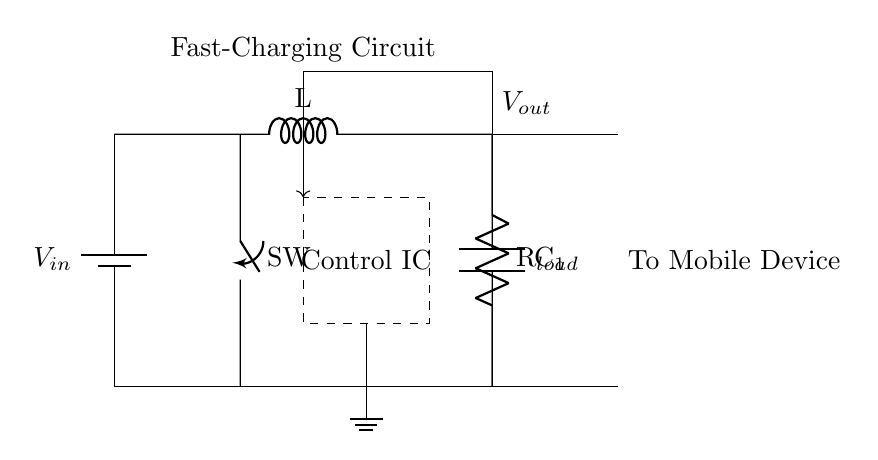What is the input voltage of this circuit? The voltage is indicated as V in the battery symbol at the start of the circuit, where the power source is labeled as V in the schematic.
Answer: V What is the function of the switch in the circuit? The switch is used to control the flow of current, allowing the user to enable or disable the connection to the load. Its position can break or complete the circuit, influencing the charging process.
Answer: Control flow What component is responsible for voltage regulation? The control IC is responsible for managing the output voltage and ensures it stays within specified limits as the load varies. The dashed rectangle in the diagram represents this component.
Answer: Control IC How is the feedback from the output connected to the control? The feedback is represented as an arrow that links the output voltage connection back to the control IC, indicating that the output voltage information is sent back for adjustment purposes. This connection helps maintain stability and efficiency in charging.
Answer: Feedback loop What is the load resistance symbolized in this circuit? The load resistance is denoted as R in the circuit diagram. It represents the equivalent resistance faced by the output voltage when connected to the mobile device. This component is shown connected to the output and ground.
Answer: R load 